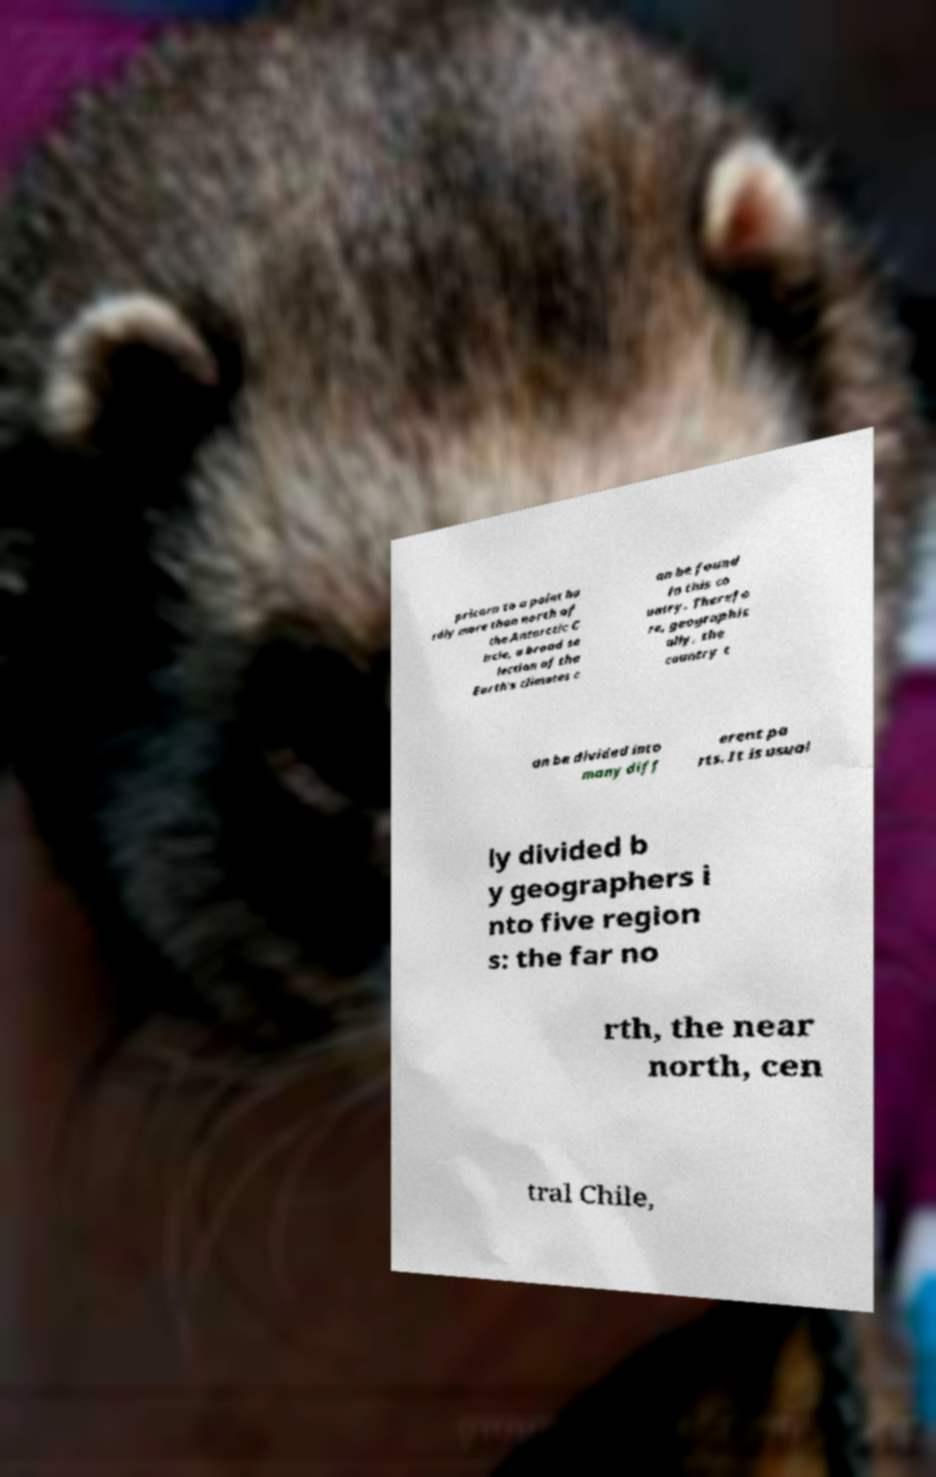Can you read and provide the text displayed in the image?This photo seems to have some interesting text. Can you extract and type it out for me? pricorn to a point ha rdly more than north of the Antarctic C ircle, a broad se lection of the Earth's climates c an be found in this co untry. Therefo re, geographic ally, the country c an be divided into many diff erent pa rts. It is usual ly divided b y geographers i nto five region s: the far no rth, the near north, cen tral Chile, 